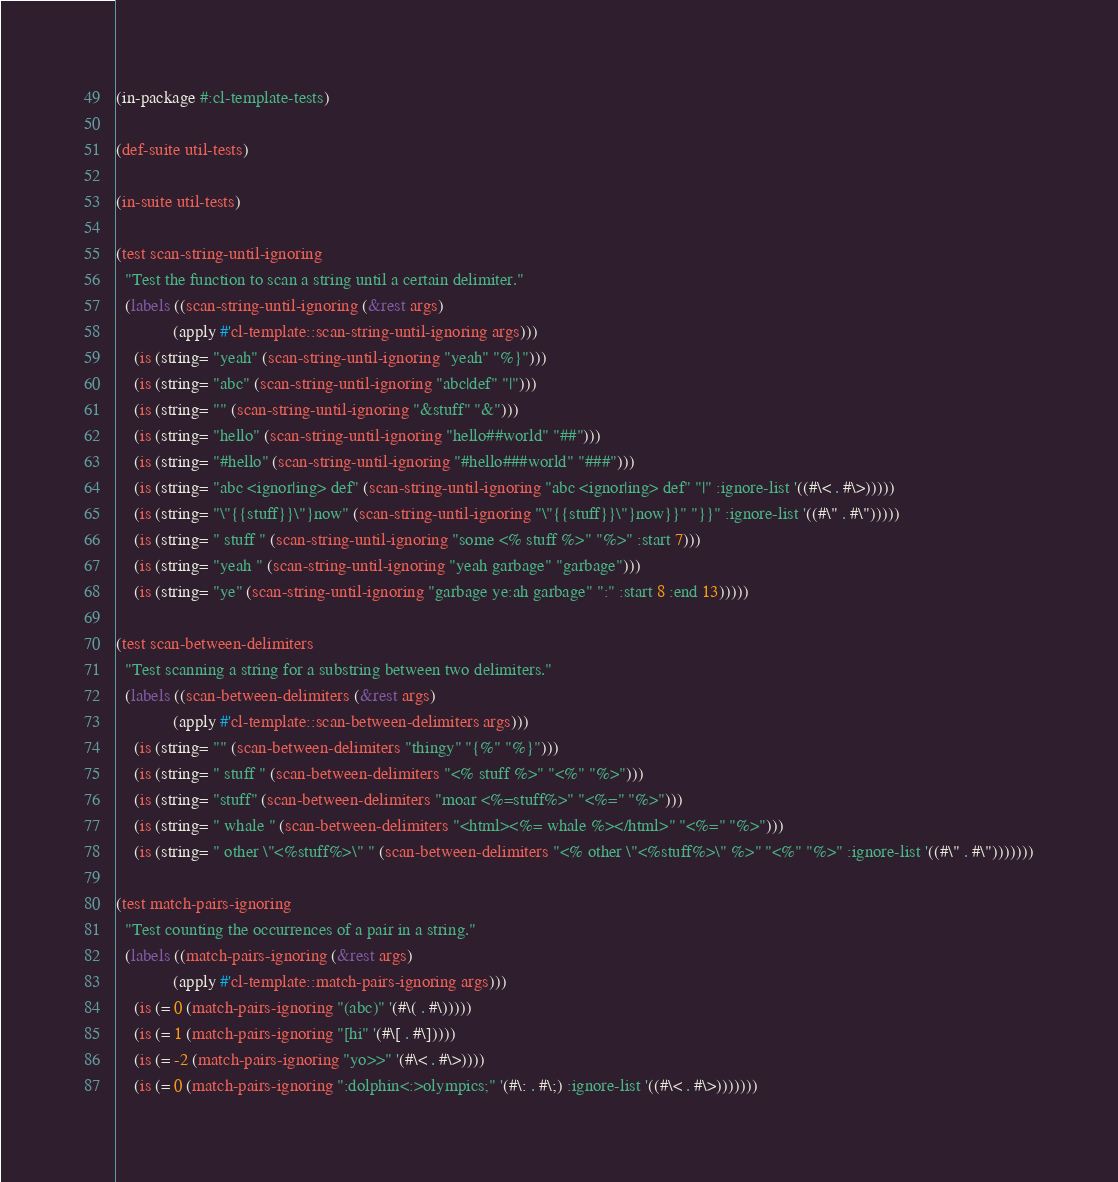<code> <loc_0><loc_0><loc_500><loc_500><_Lisp_>(in-package #:cl-template-tests)

(def-suite util-tests)

(in-suite util-tests)

(test scan-string-until-ignoring
  "Test the function to scan a string until a certain delimiter."
  (labels ((scan-string-until-ignoring (&rest args)
             (apply #'cl-template::scan-string-until-ignoring args)))
    (is (string= "yeah" (scan-string-until-ignoring "yeah" "%}")))
    (is (string= "abc" (scan-string-until-ignoring "abc|def" "|")))
    (is (string= "" (scan-string-until-ignoring "&stuff" "&")))
    (is (string= "hello" (scan-string-until-ignoring "hello##world" "##")))
    (is (string= "#hello" (scan-string-until-ignoring "#hello###world" "###")))
    (is (string= "abc <ignor|ing> def" (scan-string-until-ignoring "abc <ignor|ing> def" "|" :ignore-list '((#\< . #\>)))))
    (is (string= "\"{{stuff}}\"}now" (scan-string-until-ignoring "\"{{stuff}}\"}now}}" "}}" :ignore-list '((#\" . #\")))))
    (is (string= " stuff " (scan-string-until-ignoring "some <% stuff %>" "%>" :start 7)))
    (is (string= "yeah " (scan-string-until-ignoring "yeah garbage" "garbage")))
    (is (string= "ye" (scan-string-until-ignoring "garbage ye:ah garbage" ":" :start 8 :end 13)))))

(test scan-between-delimiters
  "Test scanning a string for a substring between two delimiters."
  (labels ((scan-between-delimiters (&rest args)
             (apply #'cl-template::scan-between-delimiters args)))
    (is (string= "" (scan-between-delimiters "thingy" "{%" "%}")))
    (is (string= " stuff " (scan-between-delimiters "<% stuff %>" "<%" "%>")))
    (is (string= "stuff" (scan-between-delimiters "moar <%=stuff%>" "<%=" "%>")))
    (is (string= " whale " (scan-between-delimiters "<html><%= whale %></html>" "<%=" "%>")))
    (is (string= " other \"<%stuff%>\" " (scan-between-delimiters "<% other \"<%stuff%>\" %>" "<%" "%>" :ignore-list '((#\" . #\")))))))

(test match-pairs-ignoring
  "Test counting the occurrences of a pair in a string."
  (labels ((match-pairs-ignoring (&rest args)
             (apply #'cl-template::match-pairs-ignoring args)))
    (is (= 0 (match-pairs-ignoring "(abc)" '(#\( . #\)))))
    (is (= 1 (match-pairs-ignoring "[hi" '(#\[ . #\]))))
    (is (= -2 (match-pairs-ignoring "yo>>" '(#\< . #\>))))
    (is (= 0 (match-pairs-ignoring ":dolphin<:>olympics;" '(#\: . #\;) :ignore-list '((#\< . #\>)))))))
</code> 